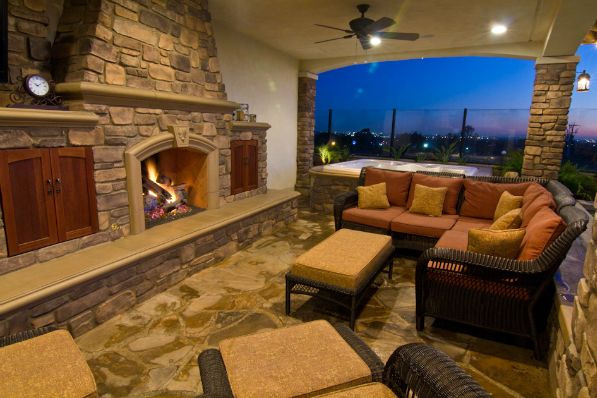What time of day does it appear to be in this image? Judging from the warm lighting and the dusk sky visible through the patio, it seems to be evening time. 